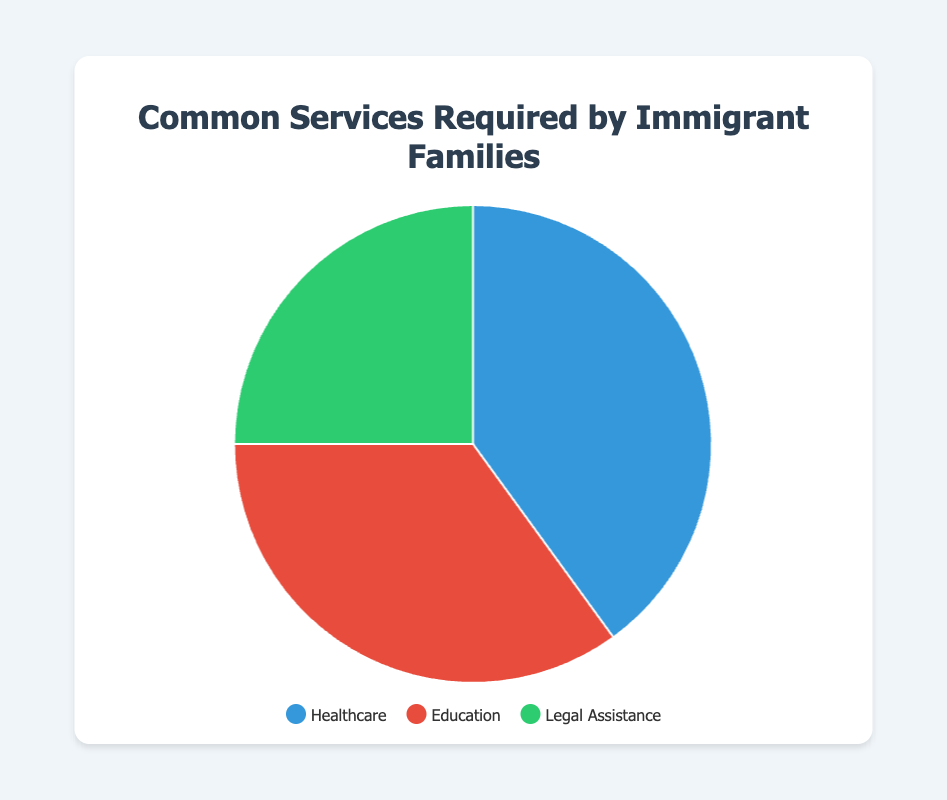What is the most required service by immigrant families? The most required service is identified by the largest section of the pie chart. The biggest section corresponds to Healthcare, which occupies 40% of the chart.
Answer: Healthcare Which service has the smallest percentage of requirement? The smallest section of the pie chart represents the least required service. Legal Assistance is the smallest section, taking up 25% of the chart.
Answer: Legal Assistance How much more percentage is allocated to Healthcare compared to Legal Assistance? To find how much more Healthcare is required than Legal Assistance, subtract the percentage of Legal Assistance from Healthcare. 40% - 25% = 15%.
Answer: 15% What is the combined percentage for Healthcare and Education services? Add the percentages of Healthcare and Education services. 40% + 35% = 75%.
Answer: 75% Which service is represented by the red section of the pie chart? The red section of the pie chart is described in the legend. The legend indicates that the red section represents Education.
Answer: Education Are Healthcare and Education services equally required? To determine if they are equally required, compare the percentages of both services. Healthcare is 40% and Education is 35%, so they are not equal.
Answer: No What percentage of services are not related to Healthcare? Subtract the percentage of Healthcare from the total (100%). 100% - 40% = 60%.
Answer: 60% Of the three services, which one is in the middle in terms of percentage? To find the middle value, list the percentages in order: 25% (Legal Assistance), 35% (Education), 40% (Healthcare). The middle value is Education with 35%.
Answer: Education How do the combined percentages of Legal Assistance and Education compare to Healthcare? Calculate the sum of Legal Assistance and Education percentages and compare it with Healthcare. Legal Assistance (25%) + Education (35%) = 60%, which is greater than Healthcare (40%).
Answer: Greater What are the visual colors representing all three services? The pie chart and legend use specific colors: Healthcare is blue, Education is red, and Legal Assistance is green.
Answer: Blue, red, green 